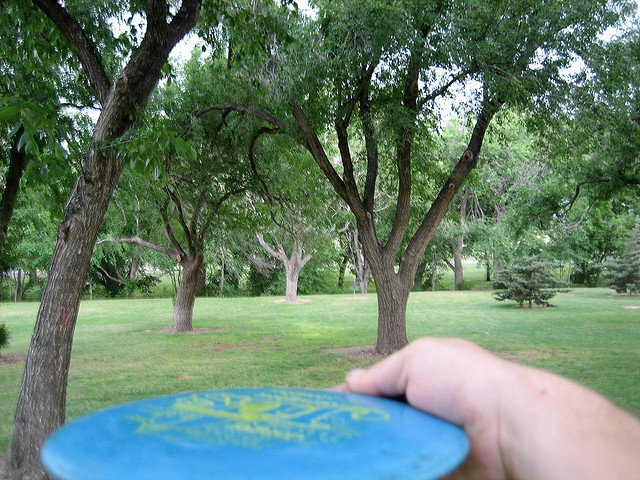Describe the objects in this image and their specific colors. I can see frisbee in black, lightblue, and lightgreen tones and people in black, pink, and darkgray tones in this image. 